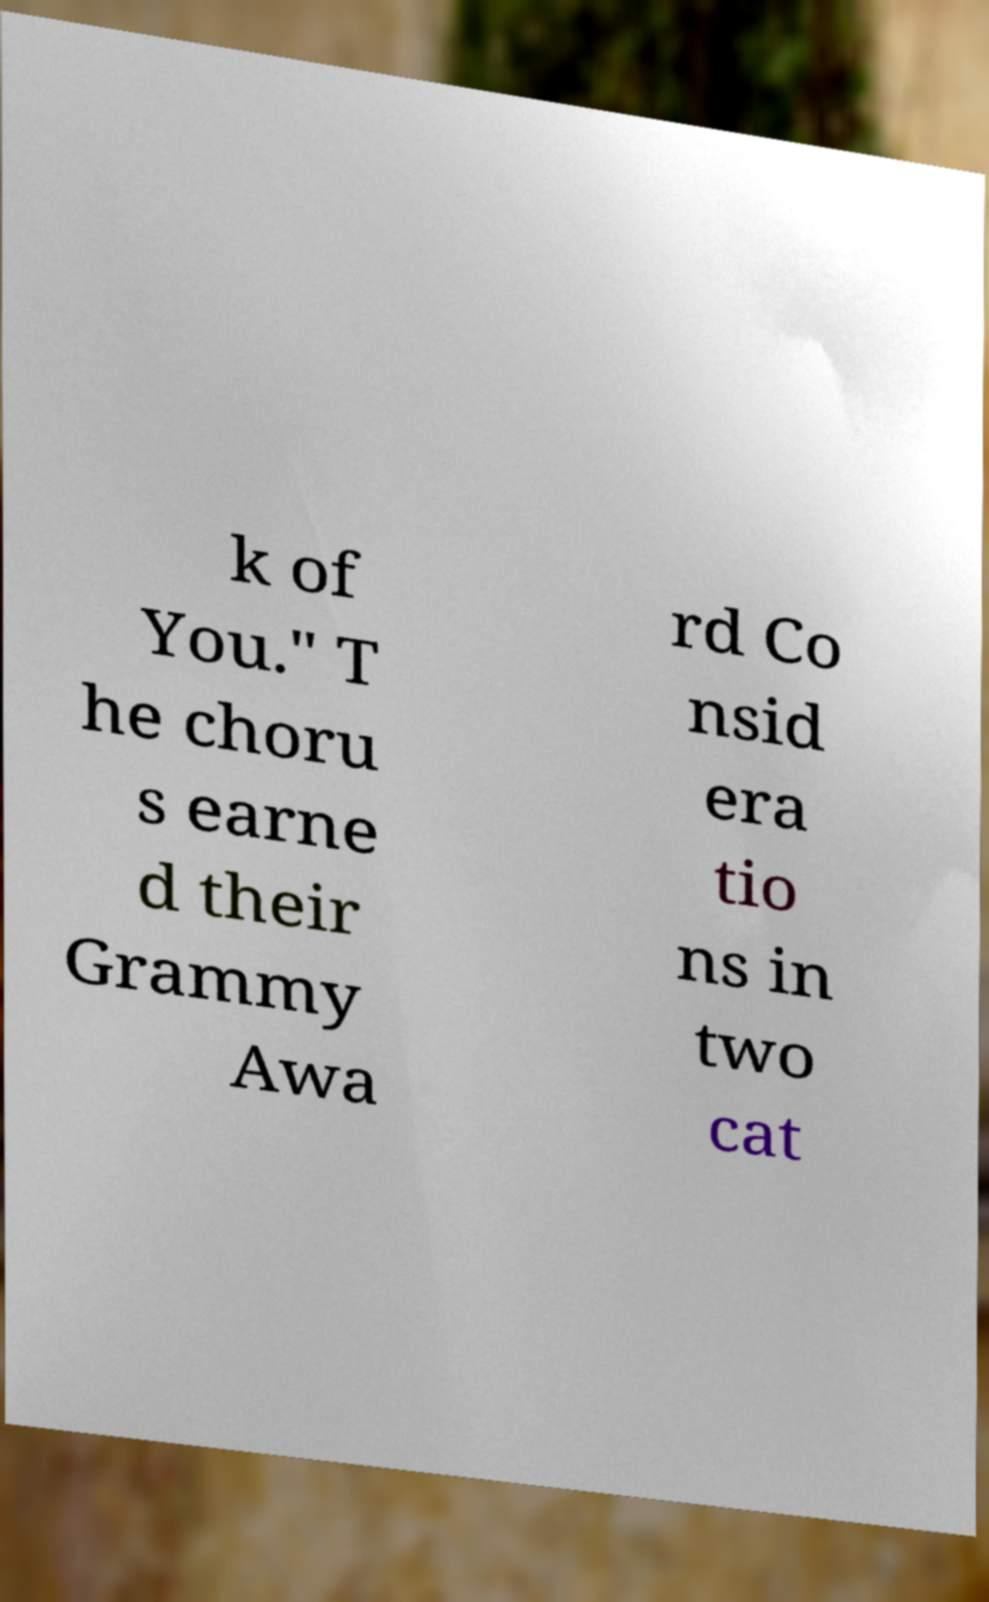Could you extract and type out the text from this image? k of You." T he choru s earne d their Grammy Awa rd Co nsid era tio ns in two cat 